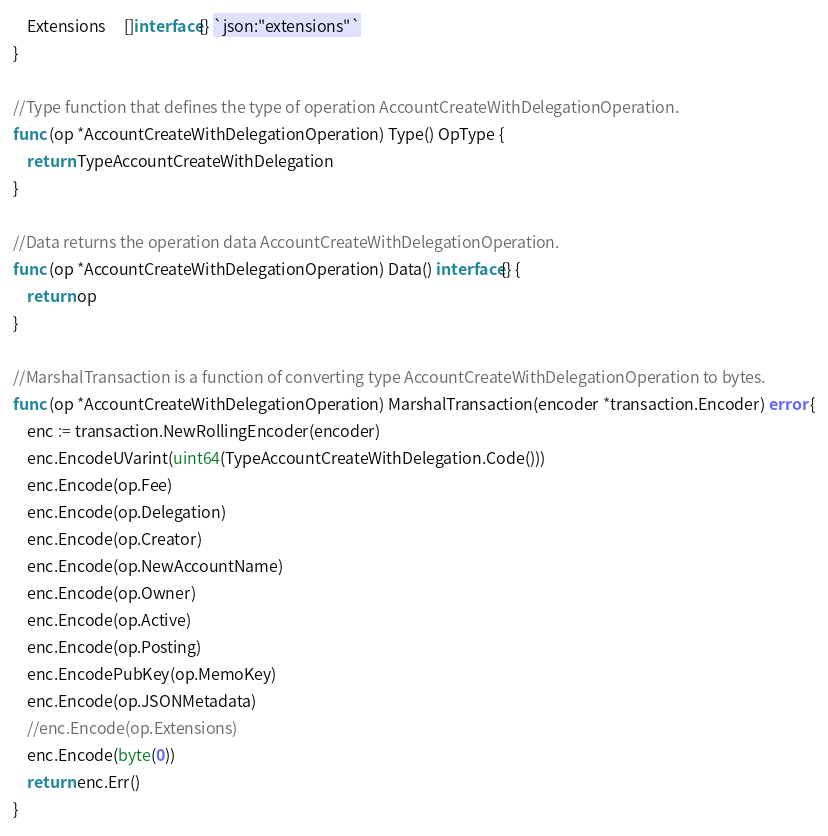<code> <loc_0><loc_0><loc_500><loc_500><_Go_>	Extensions     []interface{} `json:"extensions"`
}

//Type function that defines the type of operation AccountCreateWithDelegationOperation.
func (op *AccountCreateWithDelegationOperation) Type() OpType {
	return TypeAccountCreateWithDelegation
}

//Data returns the operation data AccountCreateWithDelegationOperation.
func (op *AccountCreateWithDelegationOperation) Data() interface{} {
	return op
}

//MarshalTransaction is a function of converting type AccountCreateWithDelegationOperation to bytes.
func (op *AccountCreateWithDelegationOperation) MarshalTransaction(encoder *transaction.Encoder) error {
	enc := transaction.NewRollingEncoder(encoder)
	enc.EncodeUVarint(uint64(TypeAccountCreateWithDelegation.Code()))
	enc.Encode(op.Fee)
	enc.Encode(op.Delegation)
	enc.Encode(op.Creator)
	enc.Encode(op.NewAccountName)
	enc.Encode(op.Owner)
	enc.Encode(op.Active)
	enc.Encode(op.Posting)
	enc.EncodePubKey(op.MemoKey)
	enc.Encode(op.JSONMetadata)
	//enc.Encode(op.Extensions)
	enc.Encode(byte(0))
	return enc.Err()
}
</code> 